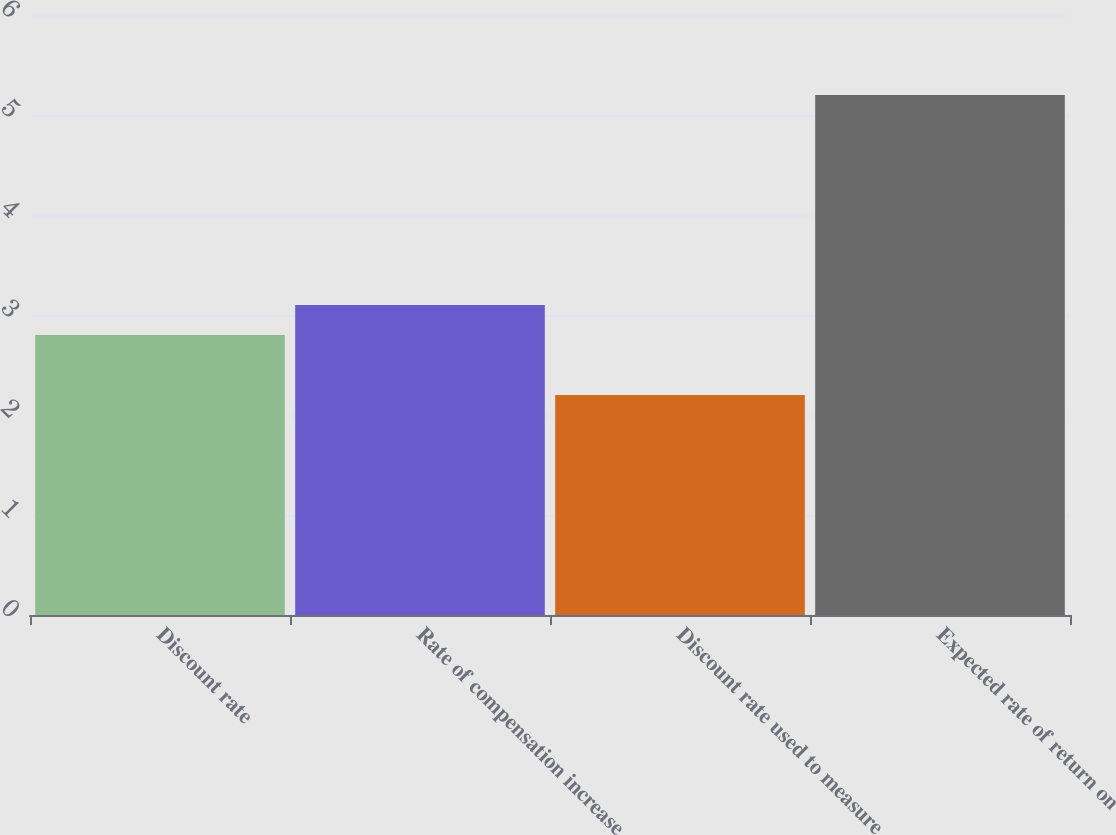Convert chart. <chart><loc_0><loc_0><loc_500><loc_500><bar_chart><fcel>Discount rate<fcel>Rate of compensation increase<fcel>Discount rate used to measure<fcel>Expected rate of return on<nl><fcel>2.8<fcel>3.1<fcel>2.2<fcel>5.2<nl></chart> 